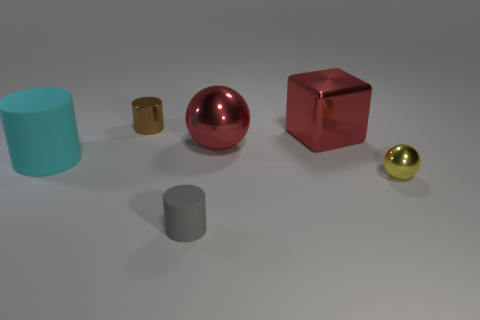Subtract all tiny cylinders. How many cylinders are left? 1 Add 4 big cyan metallic objects. How many objects exist? 10 Subtract all brown cylinders. How many cylinders are left? 2 Subtract 2 cylinders. How many cylinders are left? 1 Subtract all green spheres. Subtract all gray cubes. How many spheres are left? 2 Subtract all large metallic cubes. Subtract all small gray cubes. How many objects are left? 5 Add 2 tiny cylinders. How many tiny cylinders are left? 4 Add 4 red shiny objects. How many red shiny objects exist? 6 Subtract 0 brown cubes. How many objects are left? 6 Subtract all blocks. How many objects are left? 5 